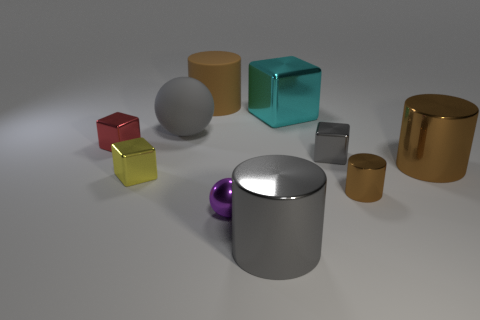Subtract all yellow blocks. How many brown cylinders are left? 3 Subtract 1 cylinders. How many cylinders are left? 3 Subtract all small metallic cylinders. How many cylinders are left? 3 Subtract all brown blocks. Subtract all brown cylinders. How many blocks are left? 4 Subtract all blocks. How many objects are left? 6 Add 8 big brown metal things. How many big brown metal things exist? 9 Subtract 0 yellow spheres. How many objects are left? 10 Subtract all gray shiny cubes. Subtract all big cubes. How many objects are left? 8 Add 8 tiny red metal things. How many tiny red metal things are left? 9 